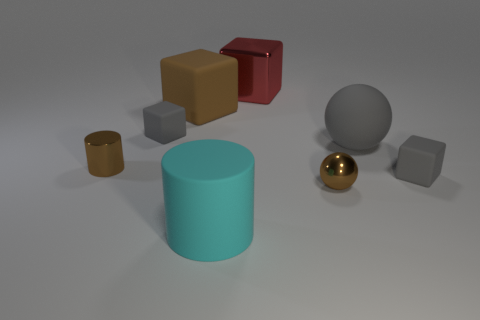Add 2 large cylinders. How many objects exist? 10 Subtract all large brown cubes. How many cubes are left? 3 Subtract all yellow cylinders. How many gray cubes are left? 2 Subtract all cylinders. How many objects are left? 6 Subtract 2 cubes. How many cubes are left? 2 Subtract all green cylinders. Subtract all gray balls. How many cylinders are left? 2 Subtract all red shiny things. Subtract all rubber balls. How many objects are left? 6 Add 7 big cyan cylinders. How many big cyan cylinders are left? 8 Add 8 large yellow rubber cylinders. How many large yellow rubber cylinders exist? 8 Subtract all brown blocks. How many blocks are left? 3 